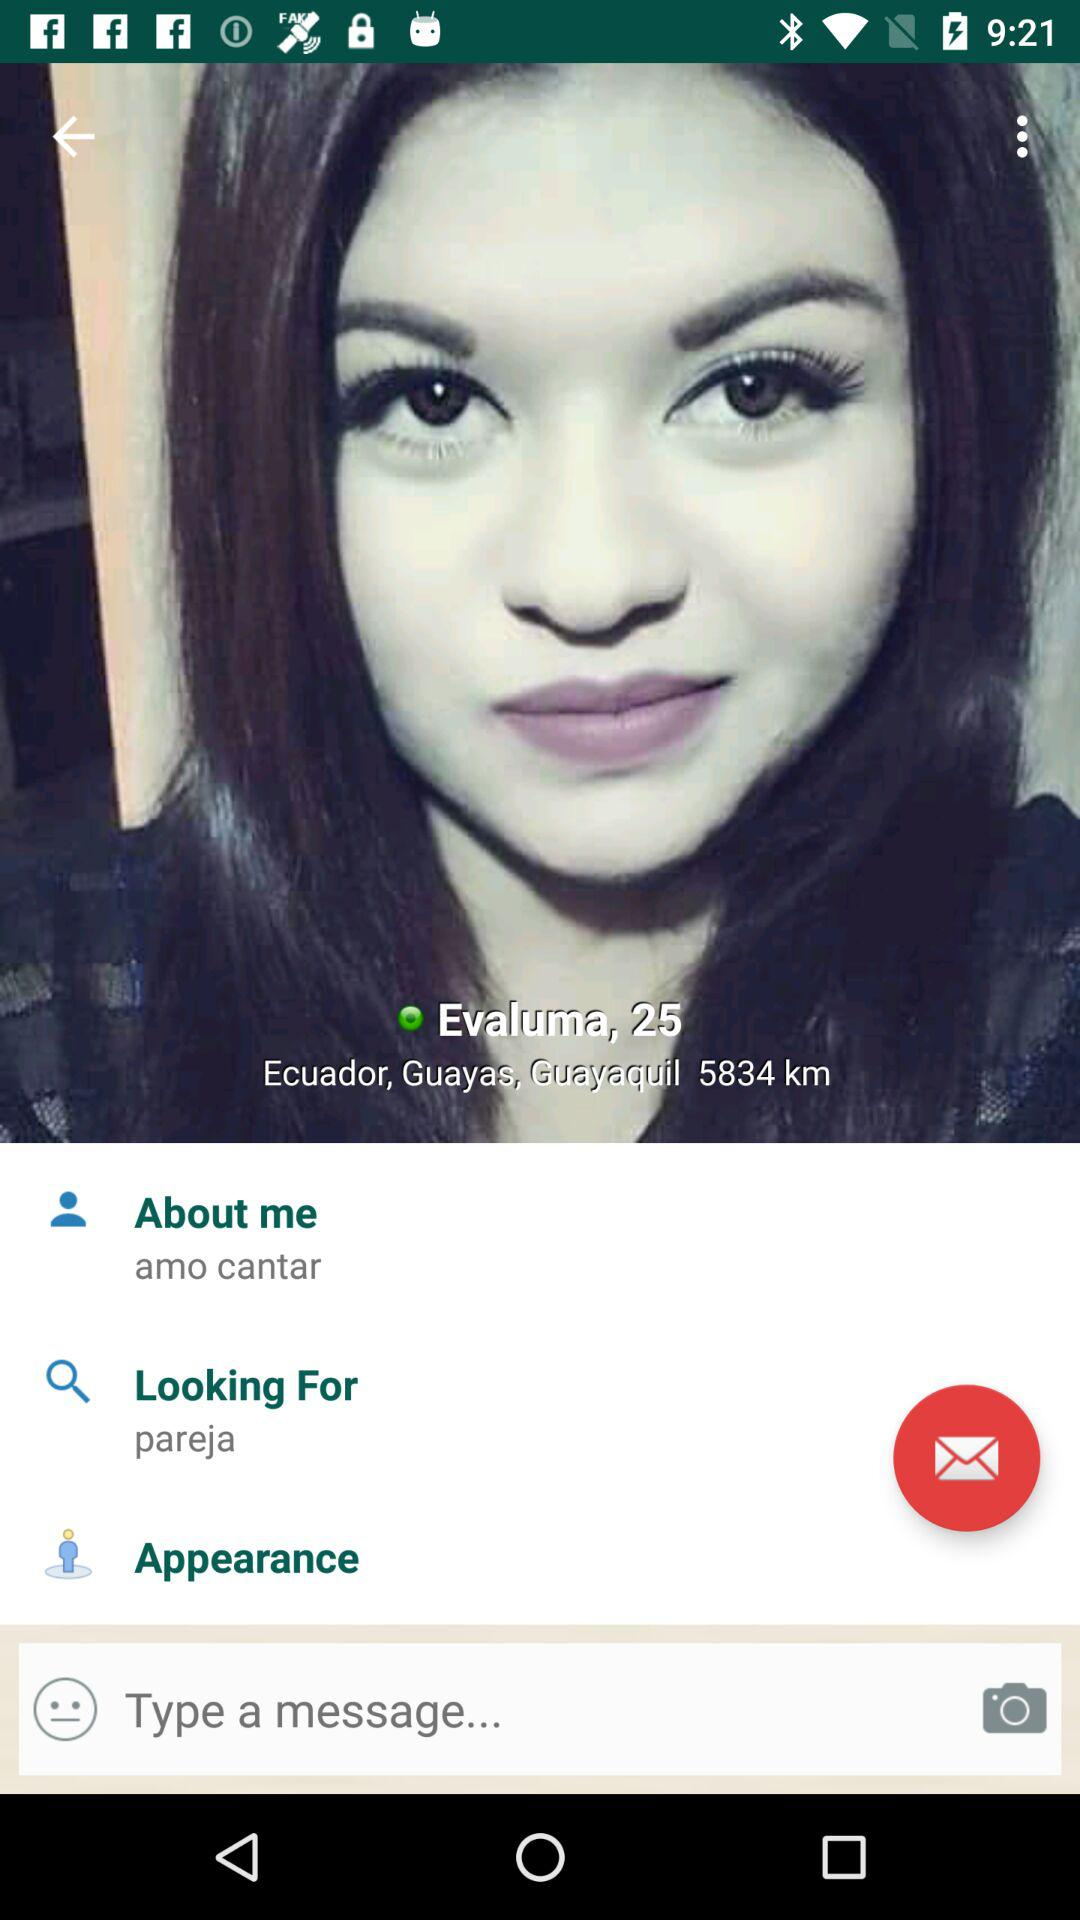What is the location? The location is Ecuador, Guayas, Guayaquil. 